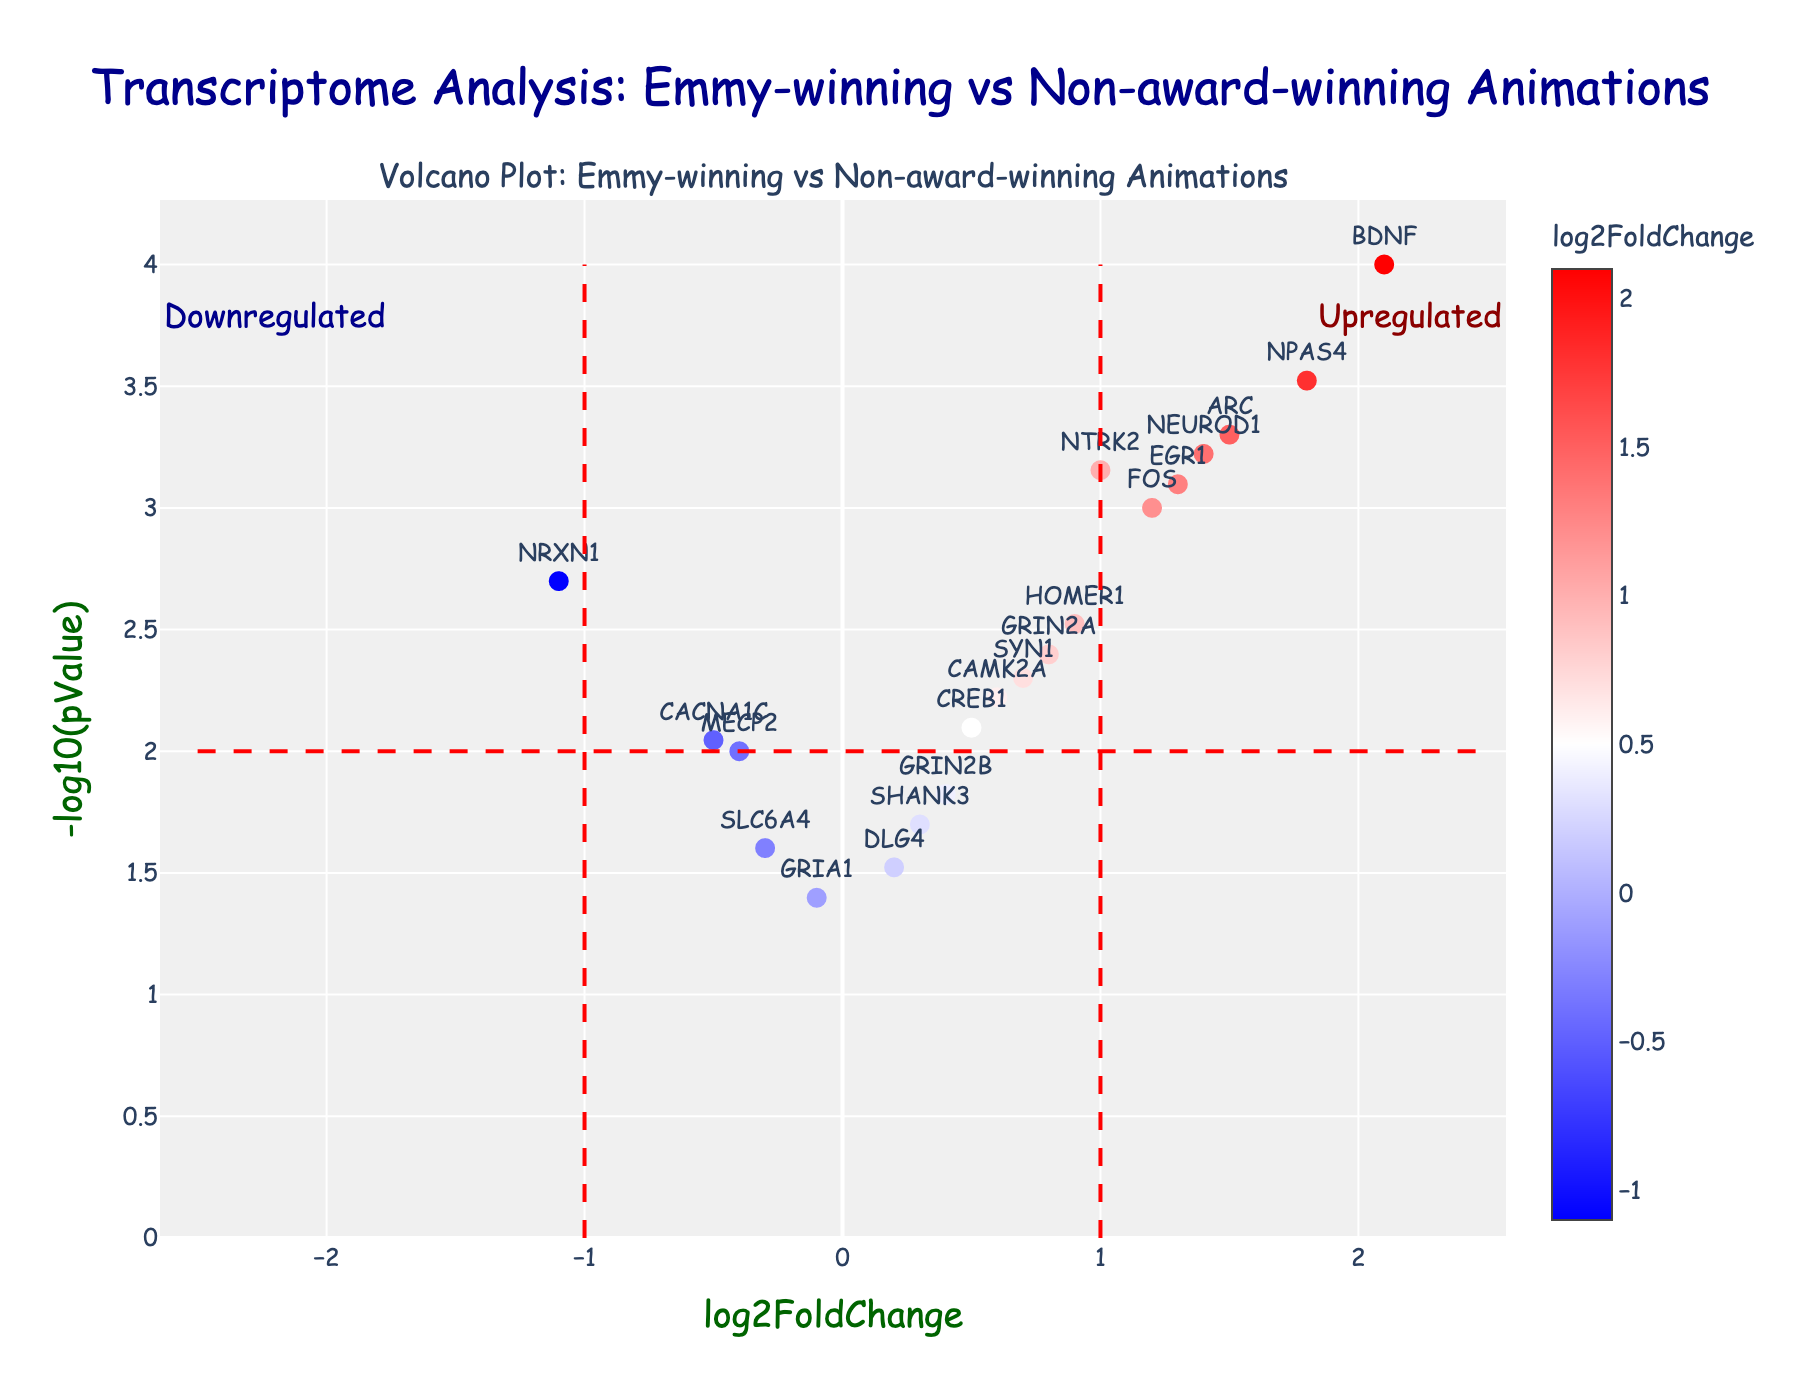What is the title of the figure? The title is situated at the top of the figure and reads: "Transcriptome Analysis: Emmy-winning vs Non-award-winning Animations".
Answer: Transcriptome Analysis: Emmy-winning vs Non-award-winning Animations What is the x-axis labeled as? The x-axis label is found below the horizontal axis of the figure and indicates "log2FoldChange".
Answer: log2FoldChange Which gene has the highest log2FoldChange value? The gene with the highest log2FoldChange value is found by locating the farthest point to the right on the x-axis, which is the BDNF gene.
Answer: BDNF How many genes show a significant change based on the set thresholds? Checking the number of data points that lie outside the vertical red dashed lines for log2FoldChange values greater than 1 and less than -1, and above the horizontal dashed line for -log10(pValue) greater than 2, reveals five genes: BDNF, NPAS4, ARC, EGR1, and FOS.
Answer: 5 What does a point with a higher -log10(pValue) indicate? Higher -log10(pValue) indicates a more statistically significant p-value, representing greater evidence against the null hypothesis, making the gene's change more significant.
Answer: More significant Which genes are considered significantly upregulated? Genes considered significantly upregulated are above the horizontal dashed line (indicating significance) and to the right of the right vertical dashed line (log2FoldChange > 1), which includes BDNF, NPAS4, and ARC.
Answer: BDNF, NPAS4, ARC What color represents the highest log2FoldChange values? The color scale transitions from blue to red, with red representing the highest log2FoldChange values.
Answer: Red Compare the log2FoldChange of NPAS4 and EGR1. Which one is higher? NPAS4 is located farther to the right compared to EGR1 on the x-axis, indicating NPAS4 has a higher log2FoldChange.
Answer: NPAS4 What is the approximate p-value for BDNF? The p-value for BDNF is derived by converting its -log10(pValue) to the p-value. With -log10(pValue) around 4, the p-value is approximately 10^-4.
Answer: 0.0001 Which gene is the most significant among those with a negative log2FoldChange? Among genes with a negative log2FoldChange, the gene highest on the y-axis, indicating the smallest p-value, is NRXN1.
Answer: NRXN1 